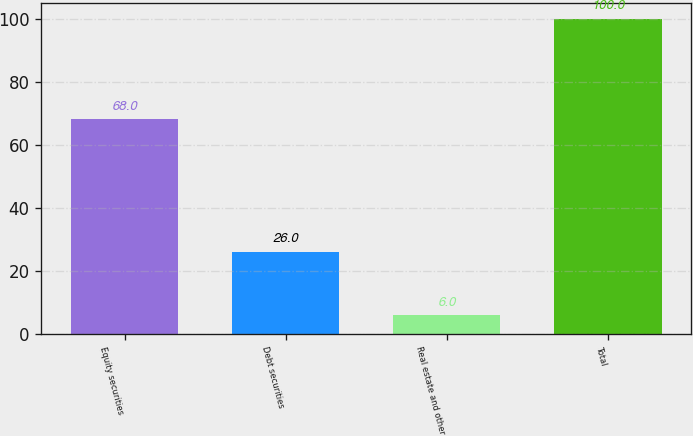Convert chart to OTSL. <chart><loc_0><loc_0><loc_500><loc_500><bar_chart><fcel>Equity securities<fcel>Debt securities<fcel>Real estate and other<fcel>Total<nl><fcel>68<fcel>26<fcel>6<fcel>100<nl></chart> 